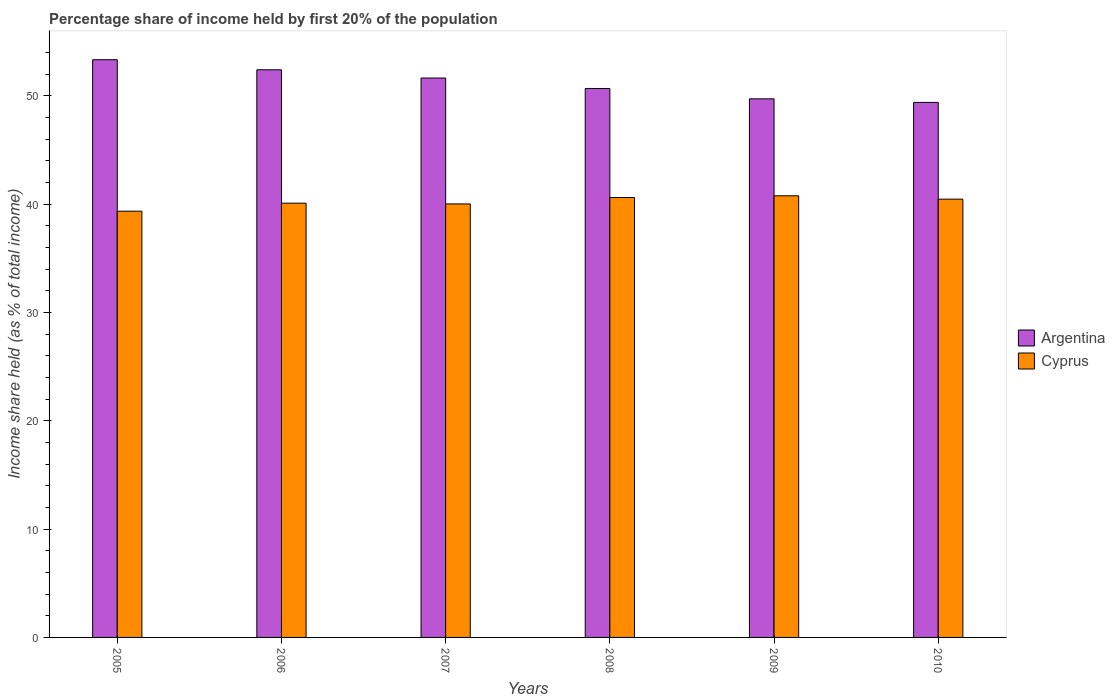How many different coloured bars are there?
Keep it short and to the point. 2. Are the number of bars on each tick of the X-axis equal?
Provide a succinct answer. Yes. How many bars are there on the 4th tick from the left?
Offer a terse response. 2. What is the label of the 6th group of bars from the left?
Offer a very short reply. 2010. In how many cases, is the number of bars for a given year not equal to the number of legend labels?
Keep it short and to the point. 0. What is the share of income held by first 20% of the population in Cyprus in 2007?
Make the answer very short. 40.01. Across all years, what is the maximum share of income held by first 20% of the population in Argentina?
Your answer should be compact. 53.32. Across all years, what is the minimum share of income held by first 20% of the population in Cyprus?
Keep it short and to the point. 39.34. In which year was the share of income held by first 20% of the population in Cyprus maximum?
Provide a short and direct response. 2009. What is the total share of income held by first 20% of the population in Argentina in the graph?
Offer a very short reply. 307.09. What is the difference between the share of income held by first 20% of the population in Cyprus in 2009 and that in 2010?
Your answer should be very brief. 0.31. What is the difference between the share of income held by first 20% of the population in Cyprus in 2007 and the share of income held by first 20% of the population in Argentina in 2006?
Offer a very short reply. -12.38. What is the average share of income held by first 20% of the population in Cyprus per year?
Your answer should be very brief. 40.21. In the year 2006, what is the difference between the share of income held by first 20% of the population in Cyprus and share of income held by first 20% of the population in Argentina?
Ensure brevity in your answer.  -12.31. What is the ratio of the share of income held by first 20% of the population in Argentina in 2006 to that in 2008?
Your response must be concise. 1.03. What is the difference between the highest and the second highest share of income held by first 20% of the population in Cyprus?
Offer a terse response. 0.16. What is the difference between the highest and the lowest share of income held by first 20% of the population in Argentina?
Keep it short and to the point. 3.94. Is the sum of the share of income held by first 20% of the population in Argentina in 2005 and 2009 greater than the maximum share of income held by first 20% of the population in Cyprus across all years?
Keep it short and to the point. Yes. What does the 2nd bar from the left in 2005 represents?
Keep it short and to the point. Cyprus. What does the 1st bar from the right in 2008 represents?
Your response must be concise. Cyprus. Are all the bars in the graph horizontal?
Give a very brief answer. No. How many years are there in the graph?
Make the answer very short. 6. Are the values on the major ticks of Y-axis written in scientific E-notation?
Provide a succinct answer. No. Does the graph contain any zero values?
Your answer should be very brief. No. Does the graph contain grids?
Your answer should be very brief. No. Where does the legend appear in the graph?
Your answer should be compact. Center right. How are the legend labels stacked?
Provide a short and direct response. Vertical. What is the title of the graph?
Give a very brief answer. Percentage share of income held by first 20% of the population. Does "Trinidad and Tobago" appear as one of the legend labels in the graph?
Keep it short and to the point. No. What is the label or title of the X-axis?
Ensure brevity in your answer.  Years. What is the label or title of the Y-axis?
Ensure brevity in your answer.  Income share held (as % of total income). What is the Income share held (as % of total income) in Argentina in 2005?
Give a very brief answer. 53.32. What is the Income share held (as % of total income) of Cyprus in 2005?
Offer a very short reply. 39.34. What is the Income share held (as % of total income) of Argentina in 2006?
Your response must be concise. 52.39. What is the Income share held (as % of total income) in Cyprus in 2006?
Keep it short and to the point. 40.08. What is the Income share held (as % of total income) in Argentina in 2007?
Give a very brief answer. 51.63. What is the Income share held (as % of total income) in Cyprus in 2007?
Keep it short and to the point. 40.01. What is the Income share held (as % of total income) in Argentina in 2008?
Offer a terse response. 50.66. What is the Income share held (as % of total income) of Cyprus in 2008?
Offer a very short reply. 40.6. What is the Income share held (as % of total income) of Argentina in 2009?
Give a very brief answer. 49.71. What is the Income share held (as % of total income) in Cyprus in 2009?
Offer a terse response. 40.76. What is the Income share held (as % of total income) of Argentina in 2010?
Keep it short and to the point. 49.38. What is the Income share held (as % of total income) of Cyprus in 2010?
Offer a very short reply. 40.45. Across all years, what is the maximum Income share held (as % of total income) of Argentina?
Provide a short and direct response. 53.32. Across all years, what is the maximum Income share held (as % of total income) of Cyprus?
Offer a terse response. 40.76. Across all years, what is the minimum Income share held (as % of total income) of Argentina?
Keep it short and to the point. 49.38. Across all years, what is the minimum Income share held (as % of total income) in Cyprus?
Your response must be concise. 39.34. What is the total Income share held (as % of total income) in Argentina in the graph?
Offer a terse response. 307.09. What is the total Income share held (as % of total income) in Cyprus in the graph?
Make the answer very short. 241.24. What is the difference between the Income share held (as % of total income) of Cyprus in 2005 and that in 2006?
Give a very brief answer. -0.74. What is the difference between the Income share held (as % of total income) of Argentina in 2005 and that in 2007?
Provide a short and direct response. 1.69. What is the difference between the Income share held (as % of total income) in Cyprus in 2005 and that in 2007?
Provide a short and direct response. -0.67. What is the difference between the Income share held (as % of total income) in Argentina in 2005 and that in 2008?
Offer a very short reply. 2.66. What is the difference between the Income share held (as % of total income) in Cyprus in 2005 and that in 2008?
Your answer should be very brief. -1.26. What is the difference between the Income share held (as % of total income) in Argentina in 2005 and that in 2009?
Your answer should be compact. 3.61. What is the difference between the Income share held (as % of total income) of Cyprus in 2005 and that in 2009?
Your answer should be compact. -1.42. What is the difference between the Income share held (as % of total income) in Argentina in 2005 and that in 2010?
Provide a short and direct response. 3.94. What is the difference between the Income share held (as % of total income) in Cyprus in 2005 and that in 2010?
Keep it short and to the point. -1.11. What is the difference between the Income share held (as % of total income) in Argentina in 2006 and that in 2007?
Make the answer very short. 0.76. What is the difference between the Income share held (as % of total income) of Cyprus in 2006 and that in 2007?
Make the answer very short. 0.07. What is the difference between the Income share held (as % of total income) in Argentina in 2006 and that in 2008?
Your response must be concise. 1.73. What is the difference between the Income share held (as % of total income) in Cyprus in 2006 and that in 2008?
Offer a very short reply. -0.52. What is the difference between the Income share held (as % of total income) of Argentina in 2006 and that in 2009?
Offer a very short reply. 2.68. What is the difference between the Income share held (as % of total income) of Cyprus in 2006 and that in 2009?
Offer a very short reply. -0.68. What is the difference between the Income share held (as % of total income) of Argentina in 2006 and that in 2010?
Make the answer very short. 3.01. What is the difference between the Income share held (as % of total income) in Cyprus in 2006 and that in 2010?
Your response must be concise. -0.37. What is the difference between the Income share held (as % of total income) in Argentina in 2007 and that in 2008?
Your answer should be compact. 0.97. What is the difference between the Income share held (as % of total income) in Cyprus in 2007 and that in 2008?
Offer a terse response. -0.59. What is the difference between the Income share held (as % of total income) of Argentina in 2007 and that in 2009?
Ensure brevity in your answer.  1.92. What is the difference between the Income share held (as % of total income) of Cyprus in 2007 and that in 2009?
Offer a terse response. -0.75. What is the difference between the Income share held (as % of total income) of Argentina in 2007 and that in 2010?
Provide a succinct answer. 2.25. What is the difference between the Income share held (as % of total income) of Cyprus in 2007 and that in 2010?
Your answer should be very brief. -0.44. What is the difference between the Income share held (as % of total income) of Argentina in 2008 and that in 2009?
Provide a succinct answer. 0.95. What is the difference between the Income share held (as % of total income) of Cyprus in 2008 and that in 2009?
Provide a short and direct response. -0.16. What is the difference between the Income share held (as % of total income) of Argentina in 2008 and that in 2010?
Offer a terse response. 1.28. What is the difference between the Income share held (as % of total income) of Cyprus in 2008 and that in 2010?
Ensure brevity in your answer.  0.15. What is the difference between the Income share held (as % of total income) in Argentina in 2009 and that in 2010?
Provide a short and direct response. 0.33. What is the difference between the Income share held (as % of total income) of Cyprus in 2009 and that in 2010?
Give a very brief answer. 0.31. What is the difference between the Income share held (as % of total income) of Argentina in 2005 and the Income share held (as % of total income) of Cyprus in 2006?
Provide a succinct answer. 13.24. What is the difference between the Income share held (as % of total income) of Argentina in 2005 and the Income share held (as % of total income) of Cyprus in 2007?
Keep it short and to the point. 13.31. What is the difference between the Income share held (as % of total income) in Argentina in 2005 and the Income share held (as % of total income) in Cyprus in 2008?
Ensure brevity in your answer.  12.72. What is the difference between the Income share held (as % of total income) of Argentina in 2005 and the Income share held (as % of total income) of Cyprus in 2009?
Your response must be concise. 12.56. What is the difference between the Income share held (as % of total income) of Argentina in 2005 and the Income share held (as % of total income) of Cyprus in 2010?
Ensure brevity in your answer.  12.87. What is the difference between the Income share held (as % of total income) in Argentina in 2006 and the Income share held (as % of total income) in Cyprus in 2007?
Your answer should be compact. 12.38. What is the difference between the Income share held (as % of total income) in Argentina in 2006 and the Income share held (as % of total income) in Cyprus in 2008?
Offer a very short reply. 11.79. What is the difference between the Income share held (as % of total income) of Argentina in 2006 and the Income share held (as % of total income) of Cyprus in 2009?
Offer a very short reply. 11.63. What is the difference between the Income share held (as % of total income) in Argentina in 2006 and the Income share held (as % of total income) in Cyprus in 2010?
Provide a succinct answer. 11.94. What is the difference between the Income share held (as % of total income) of Argentina in 2007 and the Income share held (as % of total income) of Cyprus in 2008?
Your answer should be compact. 11.03. What is the difference between the Income share held (as % of total income) of Argentina in 2007 and the Income share held (as % of total income) of Cyprus in 2009?
Keep it short and to the point. 10.87. What is the difference between the Income share held (as % of total income) of Argentina in 2007 and the Income share held (as % of total income) of Cyprus in 2010?
Make the answer very short. 11.18. What is the difference between the Income share held (as % of total income) of Argentina in 2008 and the Income share held (as % of total income) of Cyprus in 2010?
Offer a very short reply. 10.21. What is the difference between the Income share held (as % of total income) of Argentina in 2009 and the Income share held (as % of total income) of Cyprus in 2010?
Ensure brevity in your answer.  9.26. What is the average Income share held (as % of total income) of Argentina per year?
Make the answer very short. 51.18. What is the average Income share held (as % of total income) in Cyprus per year?
Ensure brevity in your answer.  40.21. In the year 2005, what is the difference between the Income share held (as % of total income) in Argentina and Income share held (as % of total income) in Cyprus?
Offer a terse response. 13.98. In the year 2006, what is the difference between the Income share held (as % of total income) in Argentina and Income share held (as % of total income) in Cyprus?
Keep it short and to the point. 12.31. In the year 2007, what is the difference between the Income share held (as % of total income) in Argentina and Income share held (as % of total income) in Cyprus?
Provide a short and direct response. 11.62. In the year 2008, what is the difference between the Income share held (as % of total income) in Argentina and Income share held (as % of total income) in Cyprus?
Make the answer very short. 10.06. In the year 2009, what is the difference between the Income share held (as % of total income) in Argentina and Income share held (as % of total income) in Cyprus?
Your answer should be very brief. 8.95. In the year 2010, what is the difference between the Income share held (as % of total income) of Argentina and Income share held (as % of total income) of Cyprus?
Keep it short and to the point. 8.93. What is the ratio of the Income share held (as % of total income) in Argentina in 2005 to that in 2006?
Offer a terse response. 1.02. What is the ratio of the Income share held (as % of total income) of Cyprus in 2005 to that in 2006?
Offer a terse response. 0.98. What is the ratio of the Income share held (as % of total income) in Argentina in 2005 to that in 2007?
Ensure brevity in your answer.  1.03. What is the ratio of the Income share held (as % of total income) in Cyprus in 2005 to that in 2007?
Keep it short and to the point. 0.98. What is the ratio of the Income share held (as % of total income) of Argentina in 2005 to that in 2008?
Your answer should be compact. 1.05. What is the ratio of the Income share held (as % of total income) in Cyprus in 2005 to that in 2008?
Your answer should be very brief. 0.97. What is the ratio of the Income share held (as % of total income) in Argentina in 2005 to that in 2009?
Make the answer very short. 1.07. What is the ratio of the Income share held (as % of total income) in Cyprus in 2005 to that in 2009?
Your answer should be very brief. 0.97. What is the ratio of the Income share held (as % of total income) of Argentina in 2005 to that in 2010?
Offer a terse response. 1.08. What is the ratio of the Income share held (as % of total income) of Cyprus in 2005 to that in 2010?
Ensure brevity in your answer.  0.97. What is the ratio of the Income share held (as % of total income) of Argentina in 2006 to that in 2007?
Provide a short and direct response. 1.01. What is the ratio of the Income share held (as % of total income) of Cyprus in 2006 to that in 2007?
Ensure brevity in your answer.  1. What is the ratio of the Income share held (as % of total income) in Argentina in 2006 to that in 2008?
Provide a succinct answer. 1.03. What is the ratio of the Income share held (as % of total income) in Cyprus in 2006 to that in 2008?
Keep it short and to the point. 0.99. What is the ratio of the Income share held (as % of total income) of Argentina in 2006 to that in 2009?
Your answer should be compact. 1.05. What is the ratio of the Income share held (as % of total income) in Cyprus in 2006 to that in 2009?
Give a very brief answer. 0.98. What is the ratio of the Income share held (as % of total income) in Argentina in 2006 to that in 2010?
Make the answer very short. 1.06. What is the ratio of the Income share held (as % of total income) of Cyprus in 2006 to that in 2010?
Your answer should be compact. 0.99. What is the ratio of the Income share held (as % of total income) of Argentina in 2007 to that in 2008?
Ensure brevity in your answer.  1.02. What is the ratio of the Income share held (as % of total income) in Cyprus in 2007 to that in 2008?
Offer a very short reply. 0.99. What is the ratio of the Income share held (as % of total income) of Argentina in 2007 to that in 2009?
Offer a terse response. 1.04. What is the ratio of the Income share held (as % of total income) in Cyprus in 2007 to that in 2009?
Provide a short and direct response. 0.98. What is the ratio of the Income share held (as % of total income) in Argentina in 2007 to that in 2010?
Offer a terse response. 1.05. What is the ratio of the Income share held (as % of total income) in Argentina in 2008 to that in 2009?
Make the answer very short. 1.02. What is the ratio of the Income share held (as % of total income) in Cyprus in 2008 to that in 2009?
Ensure brevity in your answer.  1. What is the ratio of the Income share held (as % of total income) in Argentina in 2008 to that in 2010?
Keep it short and to the point. 1.03. What is the ratio of the Income share held (as % of total income) of Cyprus in 2008 to that in 2010?
Your answer should be compact. 1. What is the ratio of the Income share held (as % of total income) in Argentina in 2009 to that in 2010?
Provide a succinct answer. 1.01. What is the ratio of the Income share held (as % of total income) of Cyprus in 2009 to that in 2010?
Ensure brevity in your answer.  1.01. What is the difference between the highest and the second highest Income share held (as % of total income) of Argentina?
Make the answer very short. 0.93. What is the difference between the highest and the second highest Income share held (as % of total income) of Cyprus?
Offer a very short reply. 0.16. What is the difference between the highest and the lowest Income share held (as % of total income) of Argentina?
Your answer should be very brief. 3.94. What is the difference between the highest and the lowest Income share held (as % of total income) of Cyprus?
Keep it short and to the point. 1.42. 